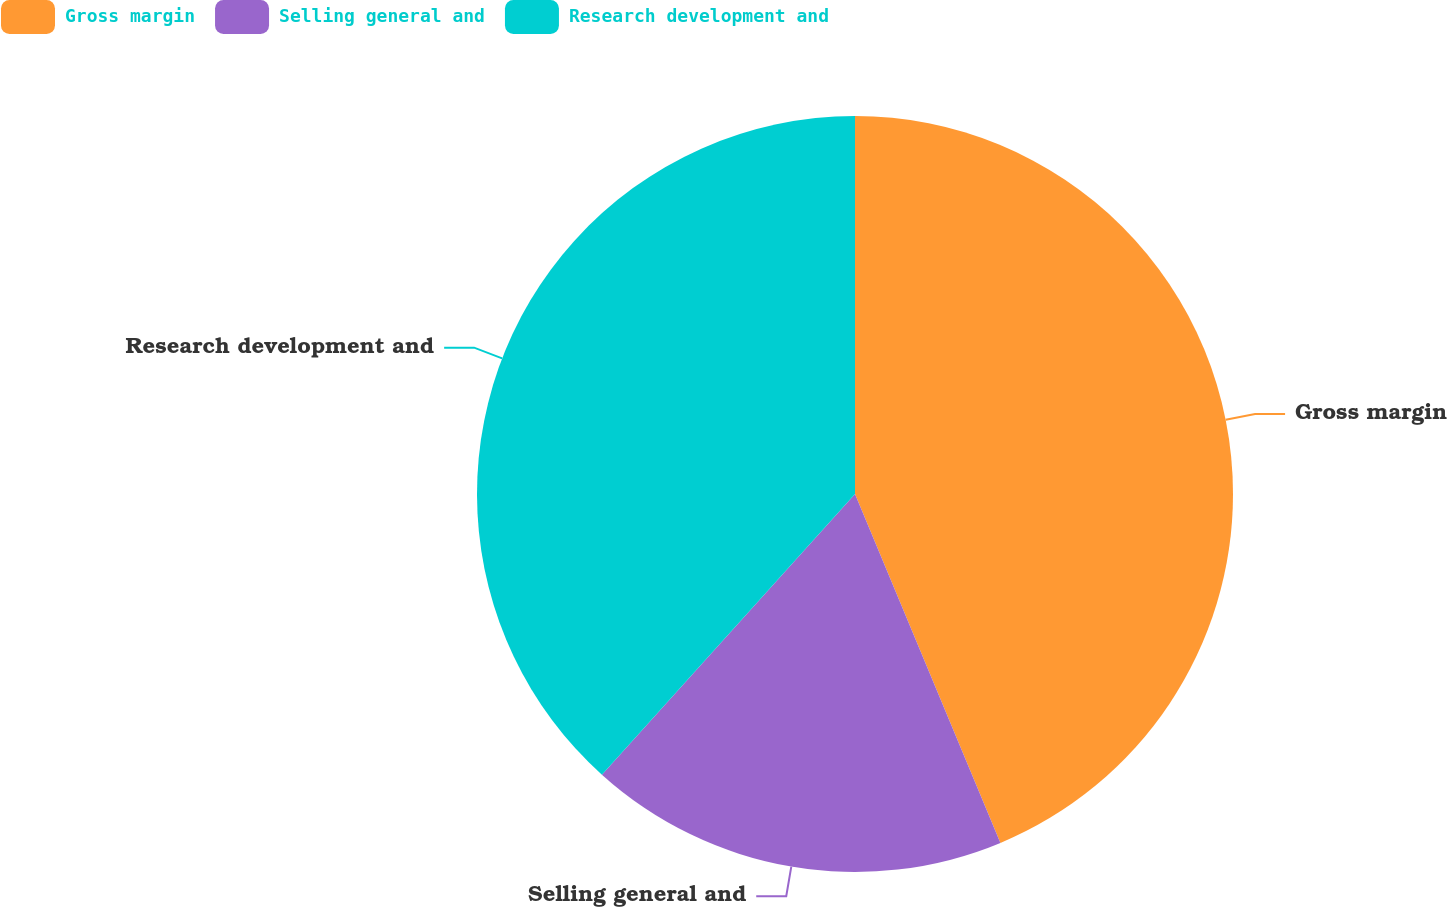<chart> <loc_0><loc_0><loc_500><loc_500><pie_chart><fcel>Gross margin<fcel>Selling general and<fcel>Research development and<nl><fcel>43.71%<fcel>17.96%<fcel>38.32%<nl></chart> 